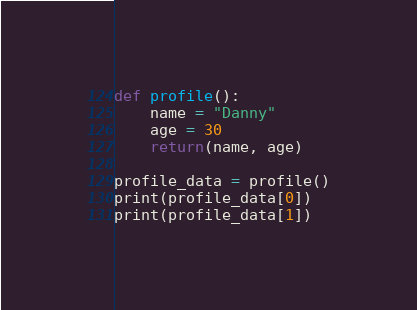Convert code to text. <code><loc_0><loc_0><loc_500><loc_500><_Python_>def profile():
    name = "Danny"
    age = 30
    return(name, age)

profile_data = profile()
print(profile_data[0])
print(profile_data[1])</code> 